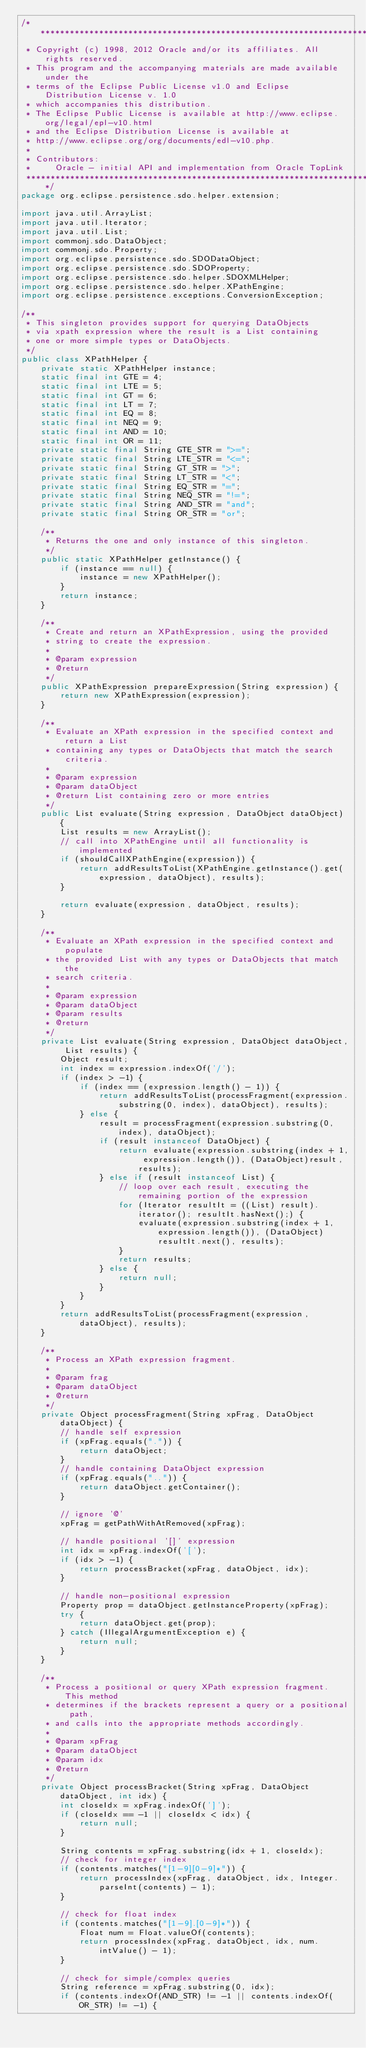<code> <loc_0><loc_0><loc_500><loc_500><_Java_>/*******************************************************************************
 * Copyright (c) 1998, 2012 Oracle and/or its affiliates. All rights reserved.
 * This program and the accompanying materials are made available under the 
 * terms of the Eclipse Public License v1.0 and Eclipse Distribution License v. 1.0 
 * which accompanies this distribution. 
 * The Eclipse Public License is available at http://www.eclipse.org/legal/epl-v10.html
 * and the Eclipse Distribution License is available at 
 * http://www.eclipse.org/org/documents/edl-v10.php.
 *
 * Contributors:
 *     Oracle - initial API and implementation from Oracle TopLink
 ******************************************************************************/ 
package org.eclipse.persistence.sdo.helper.extension;

import java.util.ArrayList;
import java.util.Iterator;
import java.util.List;
import commonj.sdo.DataObject;
import commonj.sdo.Property;
import org.eclipse.persistence.sdo.SDODataObject;
import org.eclipse.persistence.sdo.SDOProperty;
import org.eclipse.persistence.sdo.helper.SDOXMLHelper;
import org.eclipse.persistence.sdo.helper.XPathEngine;
import org.eclipse.persistence.exceptions.ConversionException;

/**
 * This singleton provides support for querying DataObjects
 * via xpath expression where the result is a List containing
 * one or more simple types or DataObjects.
 */
public class XPathHelper {
    private static XPathHelper instance;
    static final int GTE = 4;
    static final int LTE = 5;
    static final int GT = 6;
    static final int LT = 7;
    static final int EQ = 8;
    static final int NEQ = 9;
    static final int AND = 10;
    static final int OR = 11;
    private static final String GTE_STR = ">=";
    private static final String LTE_STR = "<=";
    private static final String GT_STR = ">";
    private static final String LT_STR = "<";
    private static final String EQ_STR = "=";
    private static final String NEQ_STR = "!=";
    private static final String AND_STR = "and";
    private static final String OR_STR = "or";

    /**
     * Returns the one and only instance of this singleton.
     */
    public static XPathHelper getInstance() {
        if (instance == null) {
            instance = new XPathHelper();
        }
        return instance;
    }

    /**
     * Create and return an XPathExpression, using the provided
     * string to create the expression.
     * 
     * @param expression
     * @return
     */
    public XPathExpression prepareExpression(String expression) {
        return new XPathExpression(expression);
    }
    
    /**
     * Evaluate an XPath expression in the specified context and return a List 
     * containing any types or DataObjects that match the search criteria.
     * 
     * @param expression
     * @param dataObject
     * @return List containing zero or more entries
     */
    public List evaluate(String expression, DataObject dataObject) {
        List results = new ArrayList();
        // call into XPathEngine until all functionality is implemented
        if (shouldCallXPathEngine(expression)) {
            return addResultsToList(XPathEngine.getInstance().get(expression, dataObject), results);
        }
        
        return evaluate(expression, dataObject, results);
    }

    /**
     * Evaluate an XPath expression in the specified context and populate 
     * the provided List with any types or DataObjects that match the 
     * search criteria.
     * 
     * @param expression
     * @param dataObject
     * @param results
     * @return
     */
    private List evaluate(String expression, DataObject dataObject, List results) {
        Object result;
        int index = expression.indexOf('/');
        if (index > -1) {
            if (index == (expression.length() - 1)) {
                return addResultsToList(processFragment(expression.substring(0, index), dataObject), results);
            } else {
                result = processFragment(expression.substring(0, index), dataObject);
                if (result instanceof DataObject) {
                    return evaluate(expression.substring(index + 1, expression.length()), (DataObject)result, results);
                } else if (result instanceof List) {
                    // loop over each result, executing the remaining portion of the expression
                    for (Iterator resultIt = ((List) result).iterator(); resultIt.hasNext();) {
                        evaluate(expression.substring(index + 1, expression.length()), (DataObject)resultIt.next(), results);
                    }
                    return results;
                } else {
                    return null;
                }
            }
        }
        return addResultsToList(processFragment(expression, dataObject), results);
    }
    
    /** 
     * Process an XPath expression fragment.  
     *
     * @param frag
     * @param dataObject
     * @return
     */
    private Object processFragment(String xpFrag, DataObject dataObject) {
        // handle self expression
        if (xpFrag.equals(".")) {
            return dataObject;
        }
        // handle containing DataObject expression
        if (xpFrag.equals("..")) {
            return dataObject.getContainer();
        }        
        
        // ignore '@'
        xpFrag = getPathWithAtRemoved(xpFrag);
        
        // handle positional '[]' expression
        int idx = xpFrag.indexOf('[');
        if (idx > -1) {
            return processBracket(xpFrag, dataObject, idx);
        }
        
        // handle non-positional expression
        Property prop = dataObject.getInstanceProperty(xpFrag);
        try {
            return dataObject.get(prop);
        } catch (IllegalArgumentException e) {
            return null;
        }
    }
    
    /**
     * Process a positional or query XPath expression fragment.  This method
     * determines if the brackets represent a query or a positional path, 
     * and calls into the appropriate methods accordingly.
     * 
     * @param xpFrag
     * @param dataObject
     * @param idx
     * @return
     */
    private Object processBracket(String xpFrag, DataObject dataObject, int idx) {
        int closeIdx = xpFrag.indexOf(']');
        if (closeIdx == -1 || closeIdx < idx) {
            return null;
        }

        String contents = xpFrag.substring(idx + 1, closeIdx);
        // check for integer index
        if (contents.matches("[1-9][0-9]*")) {
            return processIndex(xpFrag, dataObject, idx, Integer.parseInt(contents) - 1); 
        }

        // check for float index
        if (contents.matches("[1-9].[0-9]*")) {
            Float num = Float.valueOf(contents);
            return processIndex(xpFrag, dataObject, idx, num.intValue() - 1); 
        }

        // check for simple/complex queries
        String reference = xpFrag.substring(0, idx);
        if (contents.indexOf(AND_STR) != -1 || contents.indexOf(OR_STR) != -1) {</code> 